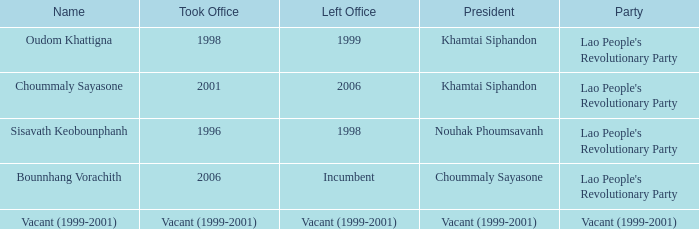What is Left Office, when Took Office is 1998? 1999.0. 